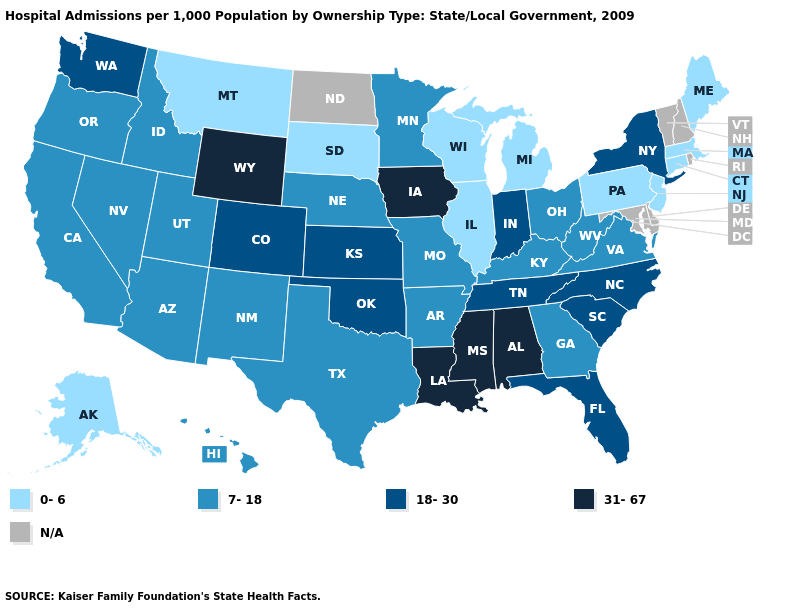Which states have the highest value in the USA?
Keep it brief. Alabama, Iowa, Louisiana, Mississippi, Wyoming. Does Pennsylvania have the highest value in the Northeast?
Quick response, please. No. What is the highest value in the USA?
Keep it brief. 31-67. What is the lowest value in the West?
Be succinct. 0-6. Name the states that have a value in the range 7-18?
Answer briefly. Arizona, Arkansas, California, Georgia, Hawaii, Idaho, Kentucky, Minnesota, Missouri, Nebraska, Nevada, New Mexico, Ohio, Oregon, Texas, Utah, Virginia, West Virginia. Name the states that have a value in the range 0-6?
Keep it brief. Alaska, Connecticut, Illinois, Maine, Massachusetts, Michigan, Montana, New Jersey, Pennsylvania, South Dakota, Wisconsin. What is the highest value in states that border Massachusetts?
Answer briefly. 18-30. Does Massachusetts have the highest value in the USA?
Give a very brief answer. No. Which states hav the highest value in the South?
Be succinct. Alabama, Louisiana, Mississippi. What is the highest value in the West ?
Write a very short answer. 31-67. Name the states that have a value in the range 0-6?
Keep it brief. Alaska, Connecticut, Illinois, Maine, Massachusetts, Michigan, Montana, New Jersey, Pennsylvania, South Dakota, Wisconsin. Which states have the highest value in the USA?
Keep it brief. Alabama, Iowa, Louisiana, Mississippi, Wyoming. Which states have the lowest value in the West?
Answer briefly. Alaska, Montana. 